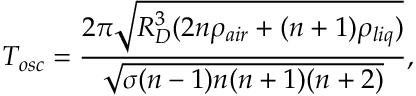<formula> <loc_0><loc_0><loc_500><loc_500>T _ { o s c } = \frac { 2 \pi \sqrt { R _ { D } ^ { 3 } ( 2 n \rho _ { a i r } + ( n + 1 ) \rho _ { l i q } ) } } { \sqrt { \sigma ( n - 1 ) n ( n + 1 ) ( n + 2 ) } } ,</formula> 